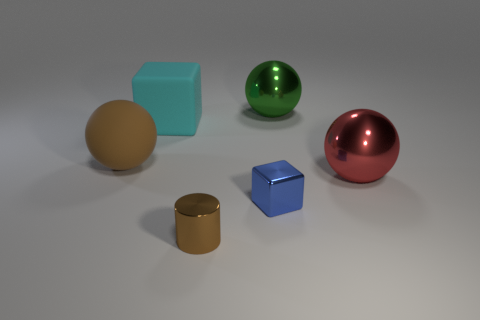Add 1 tiny blocks. How many objects exist? 7 Subtract all blocks. How many objects are left? 4 Subtract all gray matte cylinders. Subtract all spheres. How many objects are left? 3 Add 5 brown cylinders. How many brown cylinders are left? 6 Add 1 tiny brown cylinders. How many tiny brown cylinders exist? 2 Subtract 0 yellow cylinders. How many objects are left? 6 